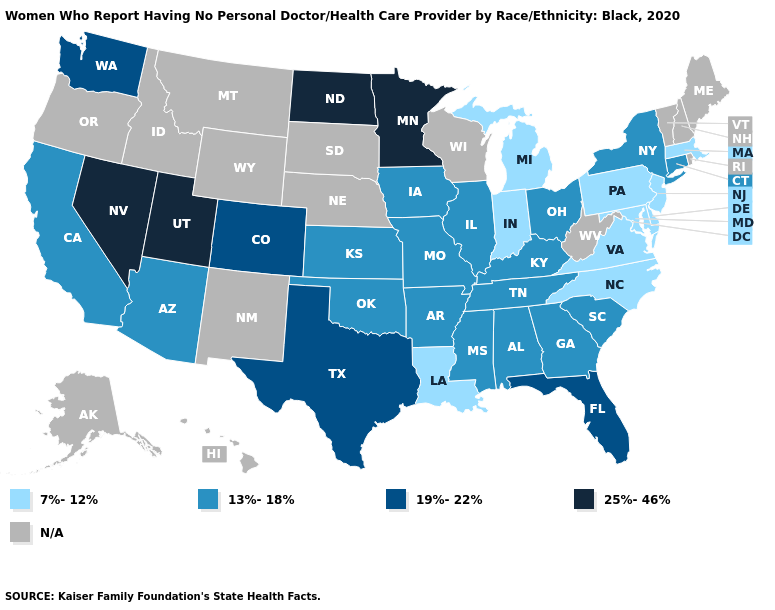What is the value of Virginia?
Keep it brief. 7%-12%. Does the first symbol in the legend represent the smallest category?
Keep it brief. Yes. What is the value of Georgia?
Concise answer only. 13%-18%. What is the value of North Carolina?
Keep it brief. 7%-12%. What is the value of Idaho?
Be succinct. N/A. Name the states that have a value in the range 13%-18%?
Short answer required. Alabama, Arizona, Arkansas, California, Connecticut, Georgia, Illinois, Iowa, Kansas, Kentucky, Mississippi, Missouri, New York, Ohio, Oklahoma, South Carolina, Tennessee. Which states have the lowest value in the USA?
Quick response, please. Delaware, Indiana, Louisiana, Maryland, Massachusetts, Michigan, New Jersey, North Carolina, Pennsylvania, Virginia. What is the value of North Dakota?
Give a very brief answer. 25%-46%. Name the states that have a value in the range 25%-46%?
Answer briefly. Minnesota, Nevada, North Dakota, Utah. What is the value of Oregon?
Be succinct. N/A. Among the states that border Arizona , does Colorado have the highest value?
Answer briefly. No. What is the value of Tennessee?
Concise answer only. 13%-18%. What is the value of Iowa?
Keep it brief. 13%-18%. Name the states that have a value in the range 7%-12%?
Be succinct. Delaware, Indiana, Louisiana, Maryland, Massachusetts, Michigan, New Jersey, North Carolina, Pennsylvania, Virginia. 